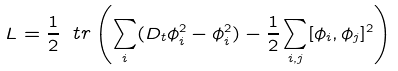<formula> <loc_0><loc_0><loc_500><loc_500>L = \frac { 1 } { 2 } \ t r \left ( \sum _ { i } ( D _ { t } \phi _ { i } ^ { 2 } - \phi _ { i } ^ { 2 } ) - \frac { 1 } { 2 } \sum _ { i , j } [ \phi _ { i } , \phi _ { j } ] ^ { 2 } \right )</formula> 